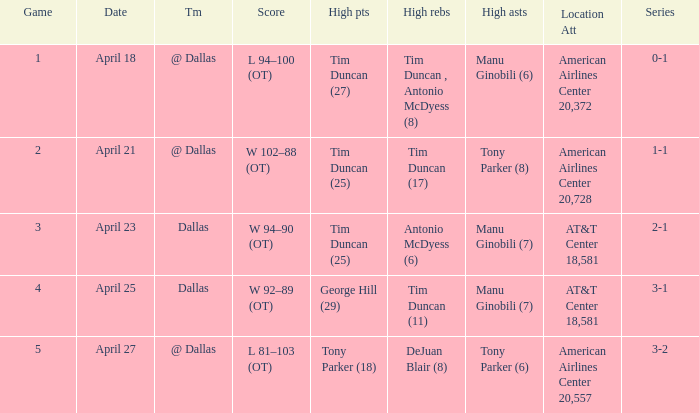When george hill (29) has the highest amount of points what is the date? April 25. 